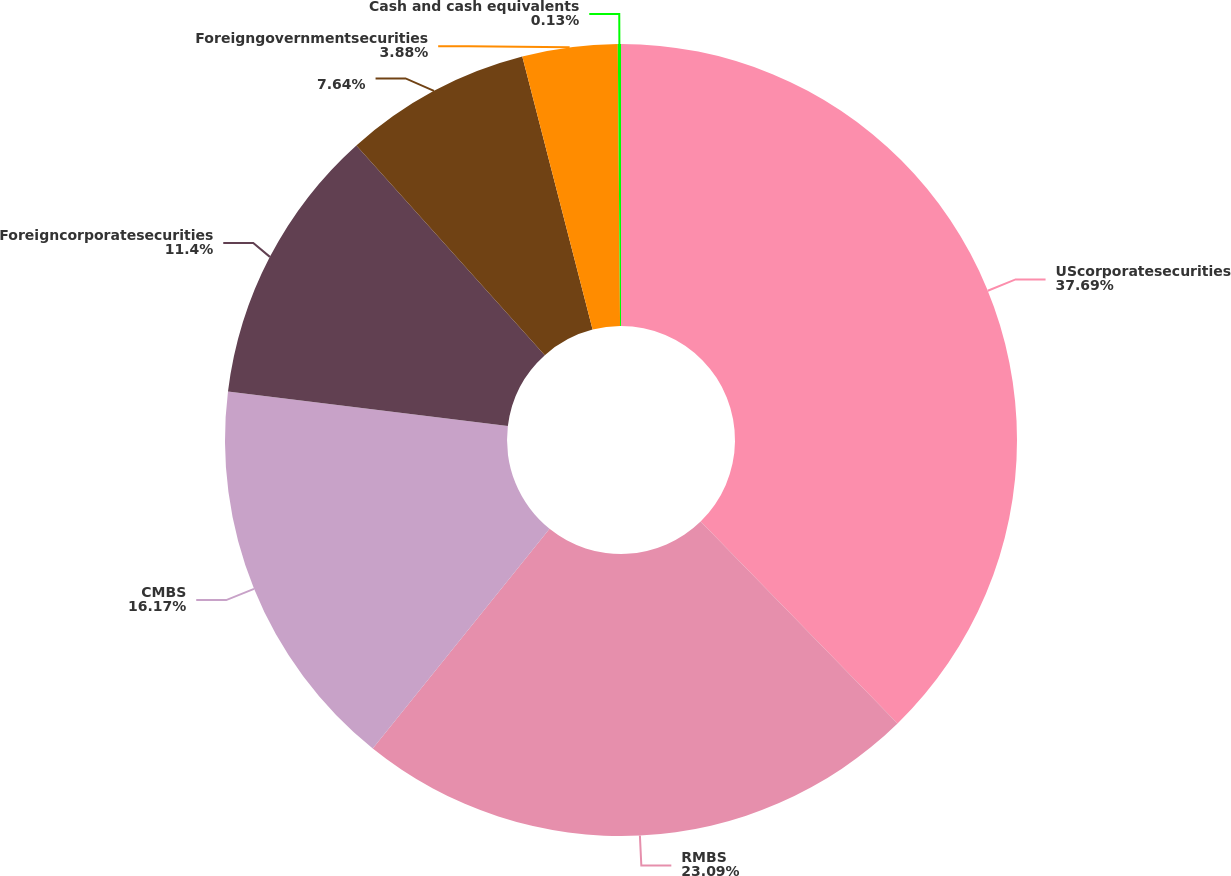Convert chart to OTSL. <chart><loc_0><loc_0><loc_500><loc_500><pie_chart><fcel>UScorporatesecurities<fcel>RMBS<fcel>CMBS<fcel>Foreigncorporatesecurities<fcel>Unnamed: 4<fcel>Foreigngovernmentsecurities<fcel>Cash and cash equivalents<nl><fcel>37.7%<fcel>23.09%<fcel>16.17%<fcel>11.4%<fcel>7.64%<fcel>3.88%<fcel>0.13%<nl></chart> 